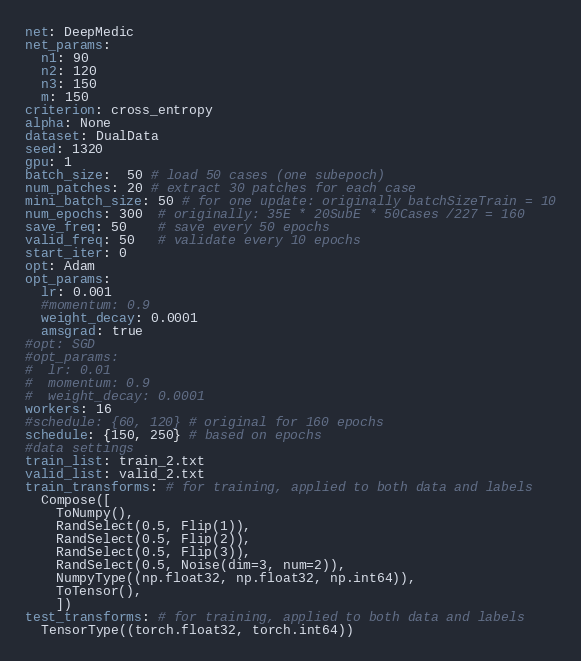<code> <loc_0><loc_0><loc_500><loc_500><_YAML_>net: DeepMedic
net_params:
  n1: 90
  n2: 120
  n3: 150
  m: 150
criterion: cross_entropy
alpha: None
dataset: DualData
seed: 1320
gpu: 1
batch_size:  50 # load 50 cases (one subepoch)
num_patches: 20 # extract 30 patches for each case
mini_batch_size: 50 # for one update: originally batchSizeTrain = 10
num_epochs: 300  # originally: 35E * 20SubE * 50Cases /227 = 160
save_freq: 50    # save every 50 epochs
valid_freq: 50   # validate every 10 epochs
start_iter: 0
opt: Adam
opt_params:
  lr: 0.001
  #momentum: 0.9
  weight_decay: 0.0001
  amsgrad: true
#opt: SGD
#opt_params:
#  lr: 0.01
#  momentum: 0.9
#  weight_decay: 0.0001
workers: 16
#schedule: {60, 120} # original for 160 epochs
schedule: {150, 250} # based on epochs
#data settings
train_list: train_2.txt
valid_list: valid_2.txt
train_transforms: # for training, applied to both data and labels
  Compose([
    ToNumpy(),
    RandSelect(0.5, Flip(1)),
    RandSelect(0.5, Flip(2)),
    RandSelect(0.5, Flip(3)),
    RandSelect(0.5, Noise(dim=3, num=2)),
    NumpyType((np.float32, np.float32, np.int64)),
    ToTensor(),
    ])
test_transforms: # for training, applied to both data and labels
  TensorType((torch.float32, torch.int64))
</code> 